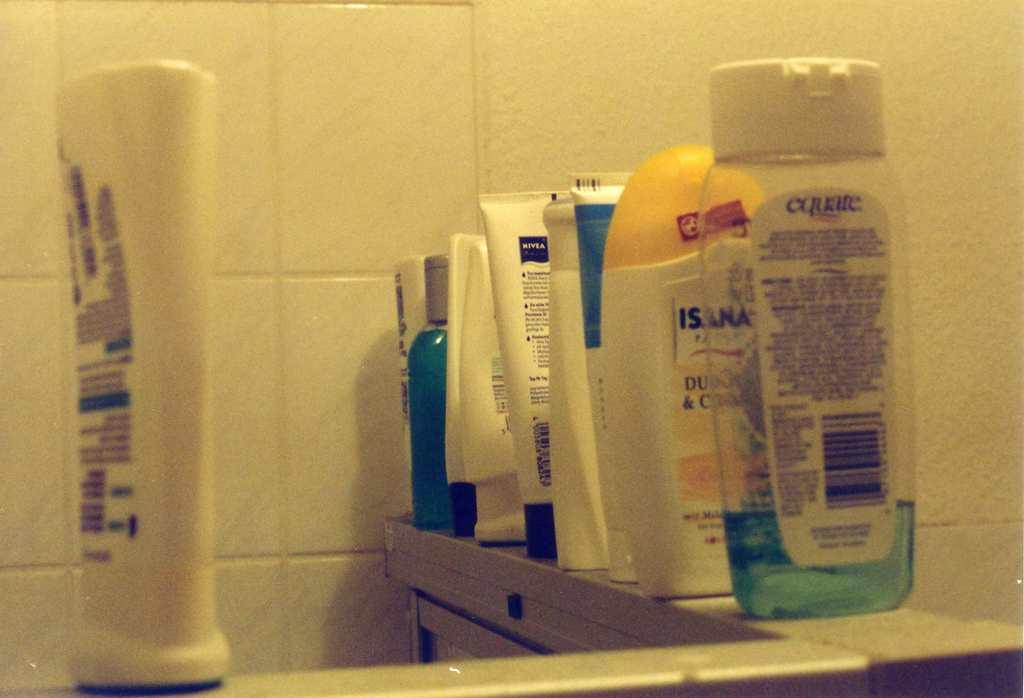<image>
Offer a succinct explanation of the picture presented. A nearly-empty bottle of Equate brand soap is among other toiletries. 